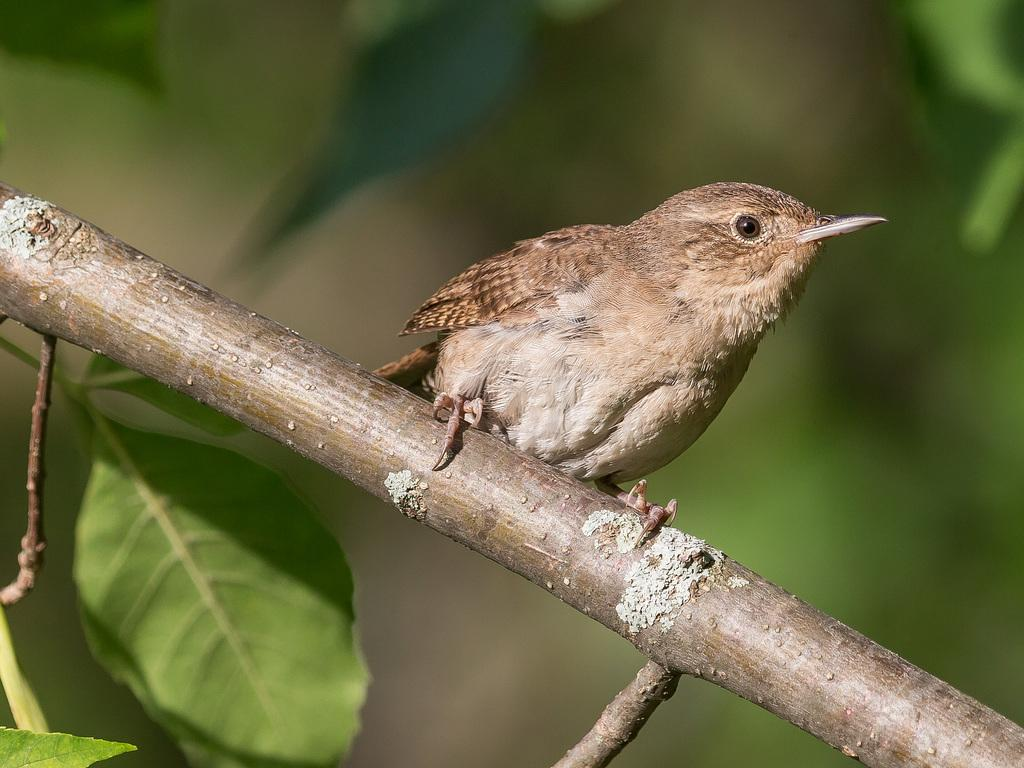What is the main subject of the image? There is a bird in the center of the image. Where is the bird located in relation to the stem? The bird is on a stem. What type of vegetation can be seen at the bottom of the image? There are leaves at the bottom of the image. What type of toe can be seen on the bird in the image? There are no visible toes on the bird in the image. Is there a plough visible in the image? No, there is no plough present in the image. 